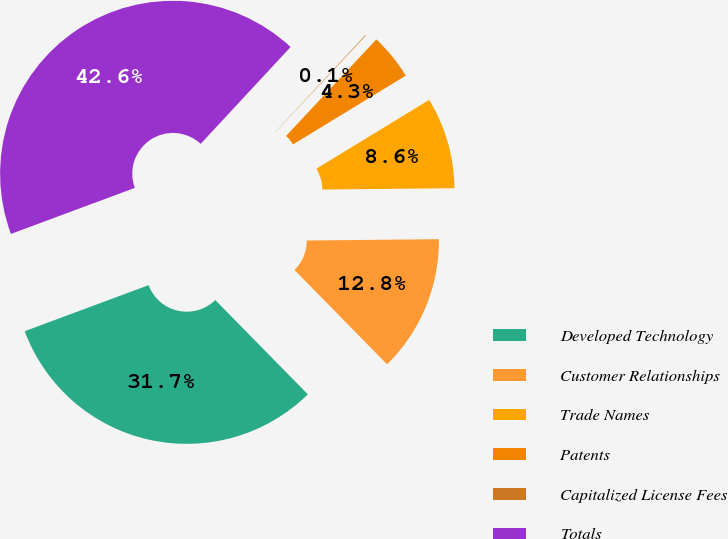Convert chart to OTSL. <chart><loc_0><loc_0><loc_500><loc_500><pie_chart><fcel>Developed Technology<fcel>Customer Relationships<fcel>Trade Names<fcel>Patents<fcel>Capitalized License Fees<fcel>Totals<nl><fcel>31.68%<fcel>12.81%<fcel>8.56%<fcel>4.31%<fcel>0.06%<fcel>42.57%<nl></chart> 